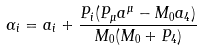Convert formula to latex. <formula><loc_0><loc_0><loc_500><loc_500>\alpha _ { i } = a _ { i } + \frac { P _ { i } ( P _ { \mu } a ^ { \mu } - M _ { 0 } a _ { 4 } ) } { M _ { 0 } ( M _ { 0 } + P _ { 4 } ) }</formula> 